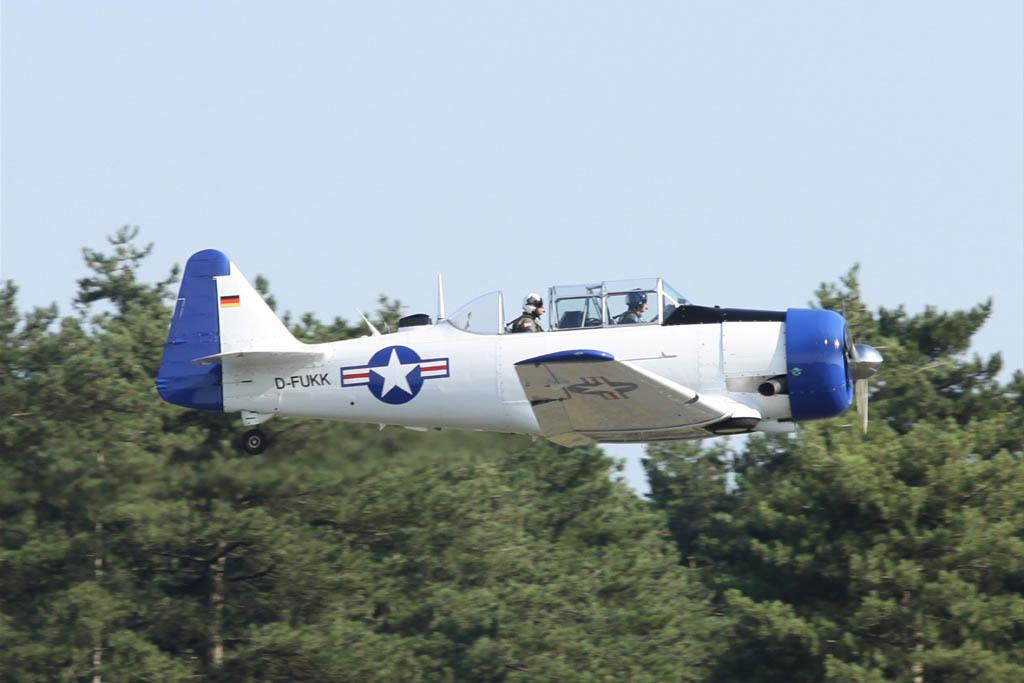What is the color of the airplane in the image? The airplane in the image is white. What is the airplane doing in the image? The airplane is flying in the sky. How many people are inside the airplane? There are 2 people inside the airplane. What type of vegetation can be seen in the image? There are trees visible in the image. Where is the desk located in the image? There is no desk present in the image. What type of disease is affecting the trees in the image? There is no indication of any disease affecting the trees in the image. 